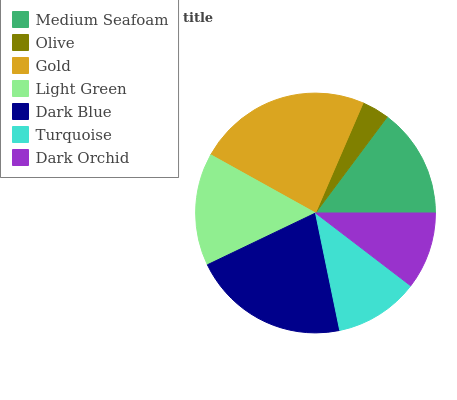Is Olive the minimum?
Answer yes or no. Yes. Is Gold the maximum?
Answer yes or no. Yes. Is Gold the minimum?
Answer yes or no. No. Is Olive the maximum?
Answer yes or no. No. Is Gold greater than Olive?
Answer yes or no. Yes. Is Olive less than Gold?
Answer yes or no. Yes. Is Olive greater than Gold?
Answer yes or no. No. Is Gold less than Olive?
Answer yes or no. No. Is Medium Seafoam the high median?
Answer yes or no. Yes. Is Medium Seafoam the low median?
Answer yes or no. Yes. Is Light Green the high median?
Answer yes or no. No. Is Dark Orchid the low median?
Answer yes or no. No. 